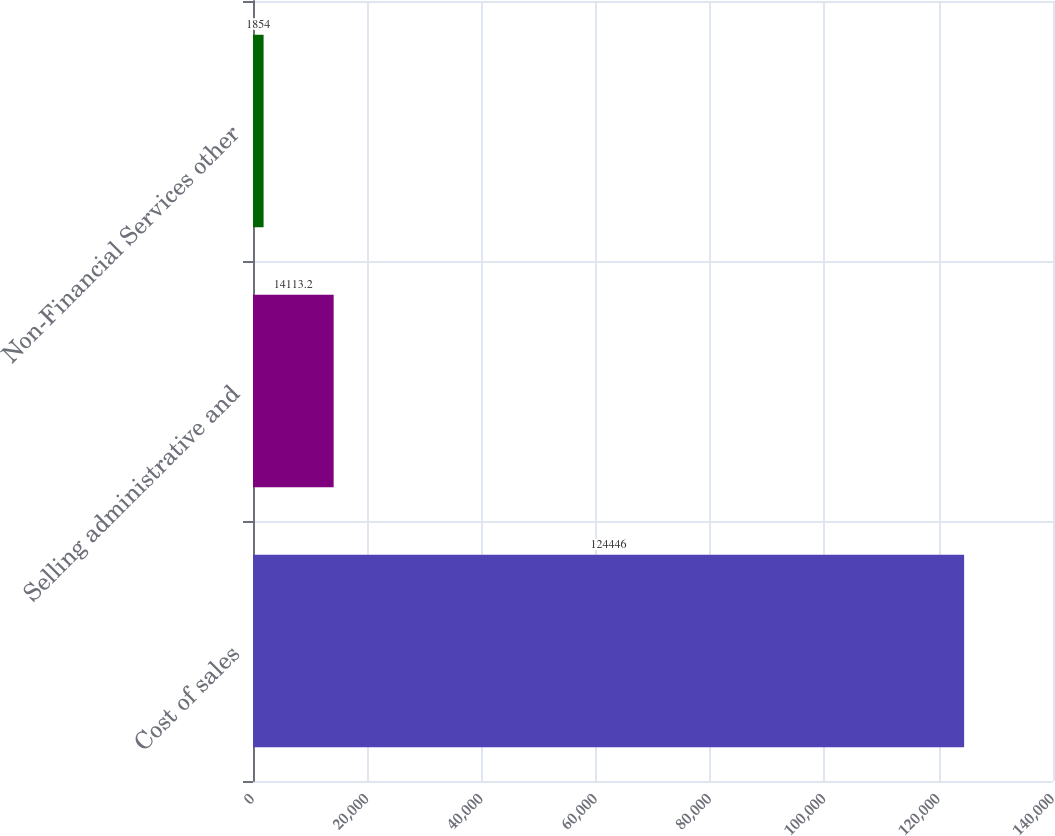Convert chart. <chart><loc_0><loc_0><loc_500><loc_500><bar_chart><fcel>Cost of sales<fcel>Selling administrative and<fcel>Non-Financial Services other<nl><fcel>124446<fcel>14113.2<fcel>1854<nl></chart> 